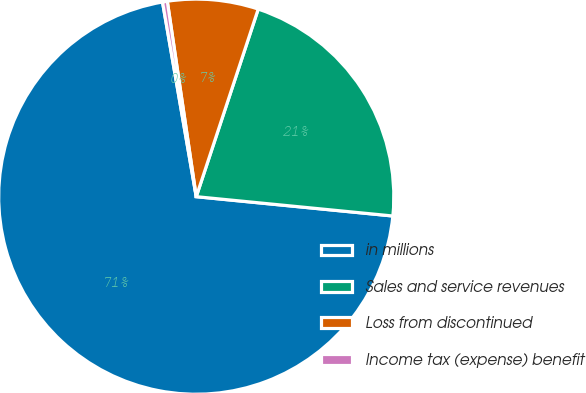Convert chart to OTSL. <chart><loc_0><loc_0><loc_500><loc_500><pie_chart><fcel>in millions<fcel>Sales and service revenues<fcel>Loss from discontinued<fcel>Income tax (expense) benefit<nl><fcel>70.71%<fcel>21.48%<fcel>7.42%<fcel>0.39%<nl></chart> 